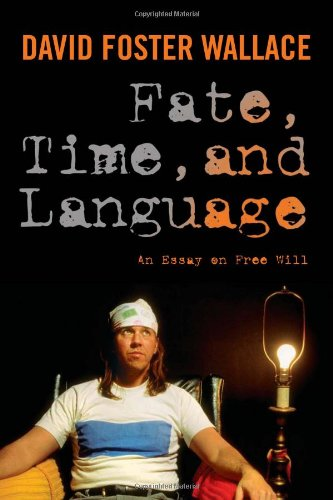What is the genre of this book? This book falls under the category of Politics & Social Sciences, specifically engaging with philosophical enquires into human freedom and societal structures. 